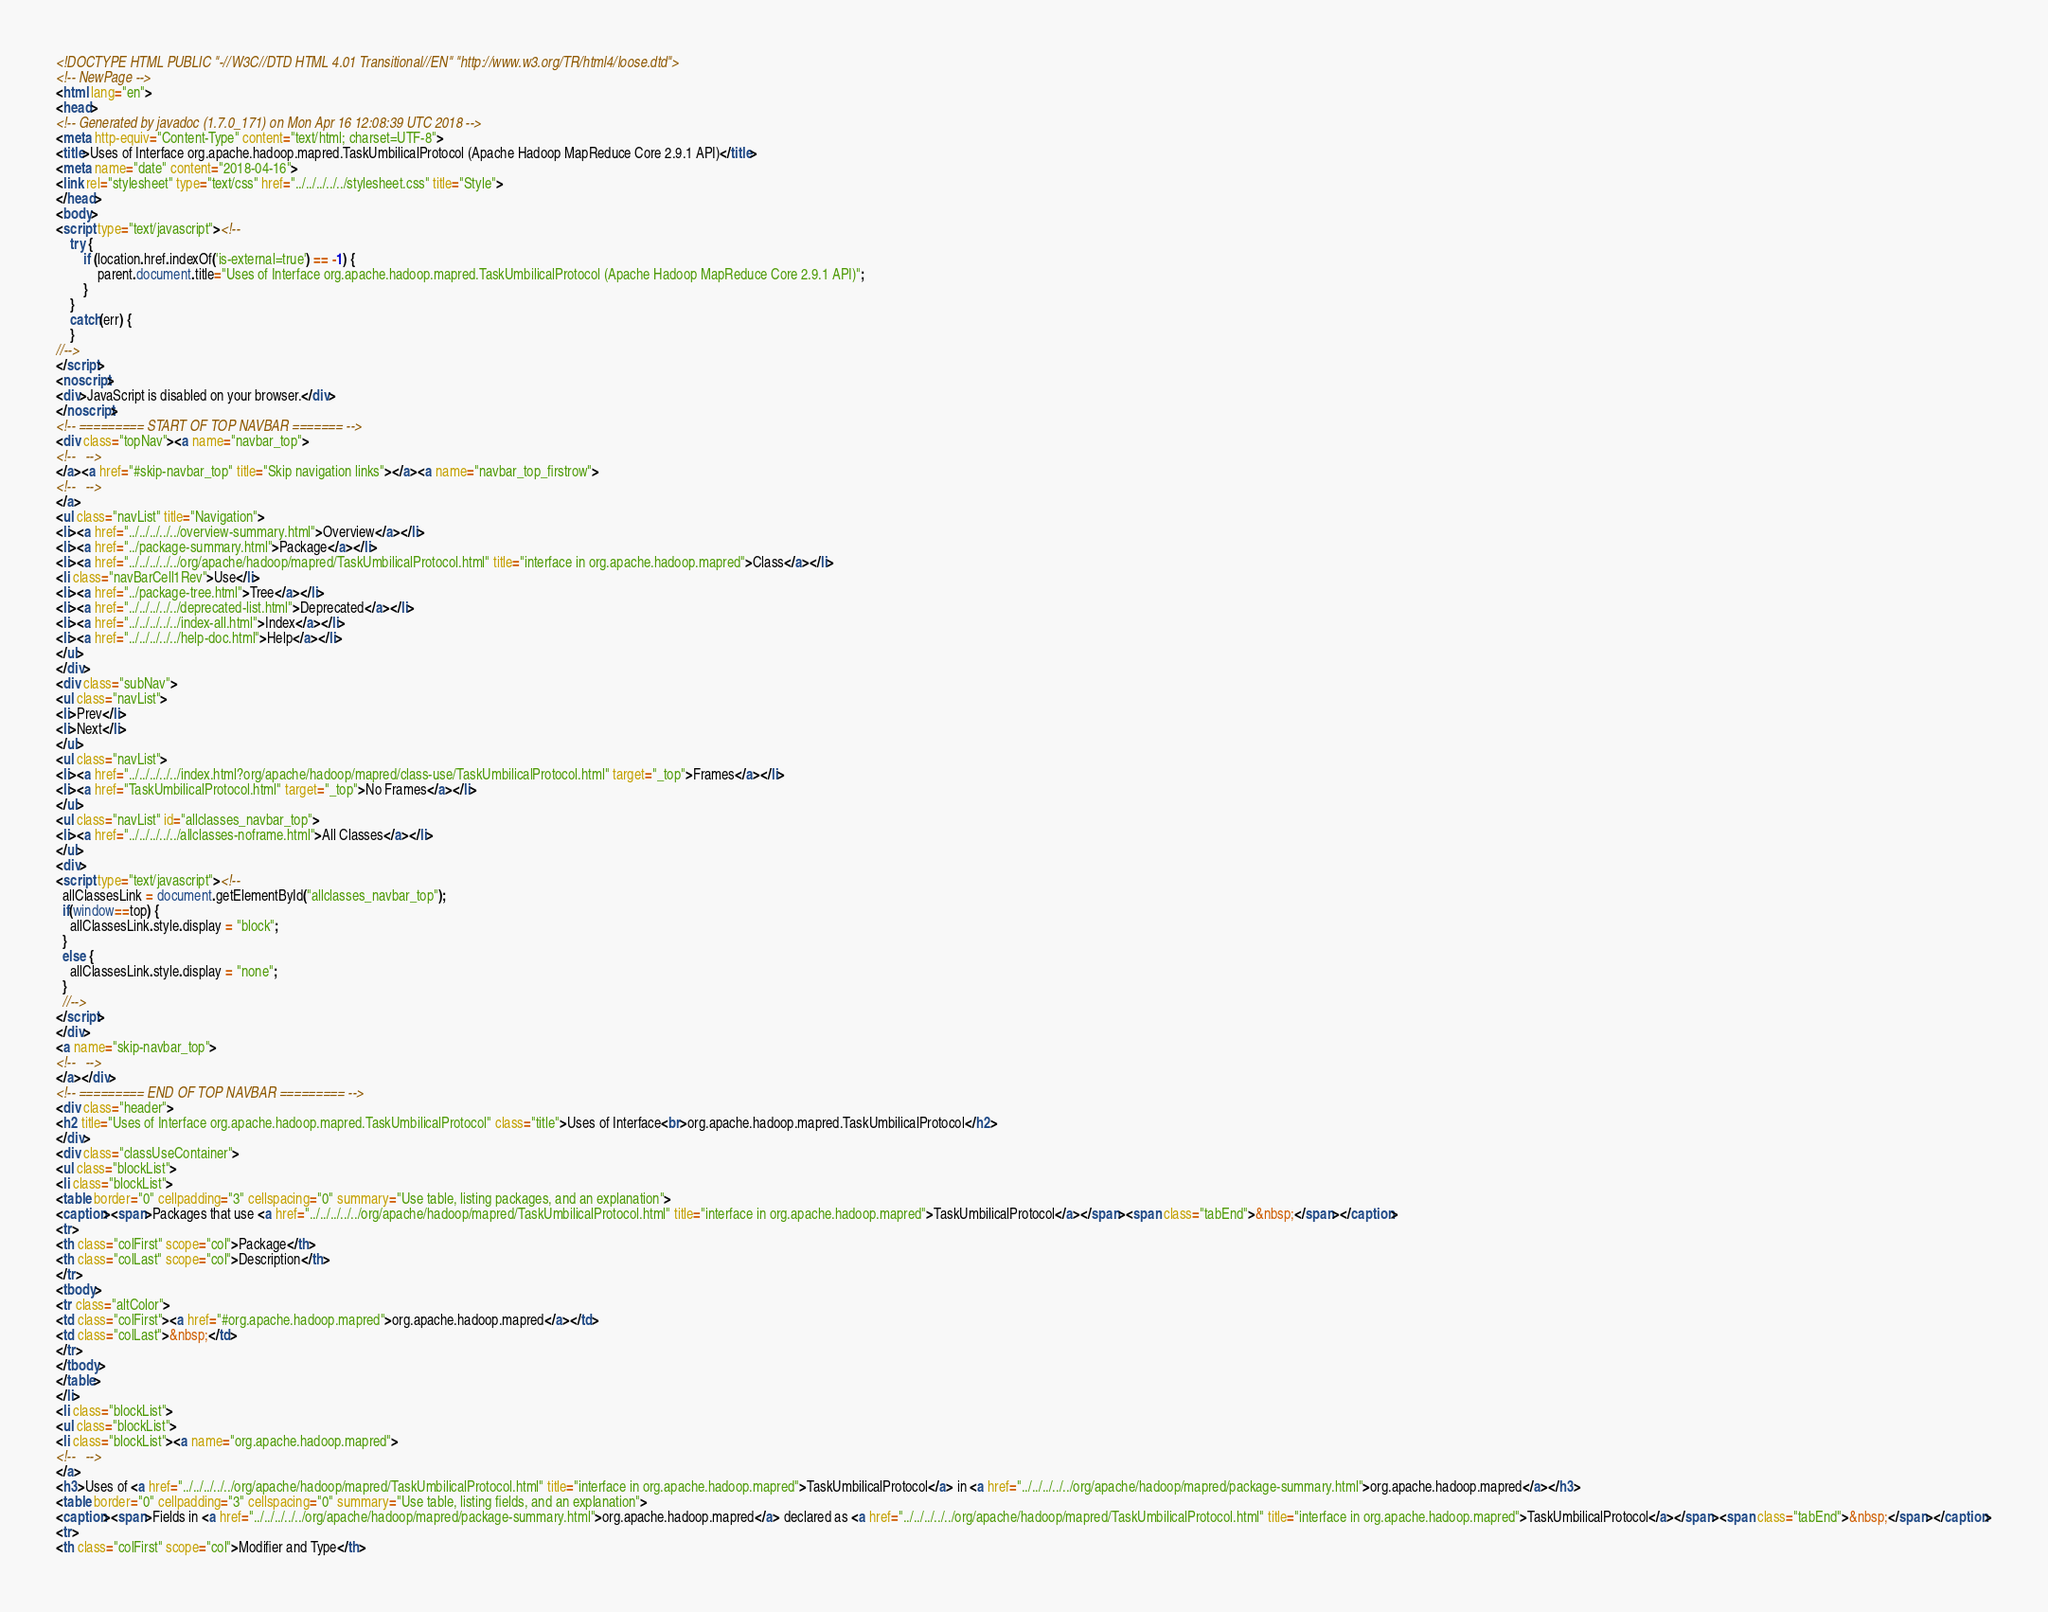Convert code to text. <code><loc_0><loc_0><loc_500><loc_500><_HTML_><!DOCTYPE HTML PUBLIC "-//W3C//DTD HTML 4.01 Transitional//EN" "http://www.w3.org/TR/html4/loose.dtd">
<!-- NewPage -->
<html lang="en">
<head>
<!-- Generated by javadoc (1.7.0_171) on Mon Apr 16 12:08:39 UTC 2018 -->
<meta http-equiv="Content-Type" content="text/html; charset=UTF-8">
<title>Uses of Interface org.apache.hadoop.mapred.TaskUmbilicalProtocol (Apache Hadoop MapReduce Core 2.9.1 API)</title>
<meta name="date" content="2018-04-16">
<link rel="stylesheet" type="text/css" href="../../../../../stylesheet.css" title="Style">
</head>
<body>
<script type="text/javascript"><!--
    try {
        if (location.href.indexOf('is-external=true') == -1) {
            parent.document.title="Uses of Interface org.apache.hadoop.mapred.TaskUmbilicalProtocol (Apache Hadoop MapReduce Core 2.9.1 API)";
        }
    }
    catch(err) {
    }
//-->
</script>
<noscript>
<div>JavaScript is disabled on your browser.</div>
</noscript>
<!-- ========= START OF TOP NAVBAR ======= -->
<div class="topNav"><a name="navbar_top">
<!--   -->
</a><a href="#skip-navbar_top" title="Skip navigation links"></a><a name="navbar_top_firstrow">
<!--   -->
</a>
<ul class="navList" title="Navigation">
<li><a href="../../../../../overview-summary.html">Overview</a></li>
<li><a href="../package-summary.html">Package</a></li>
<li><a href="../../../../../org/apache/hadoop/mapred/TaskUmbilicalProtocol.html" title="interface in org.apache.hadoop.mapred">Class</a></li>
<li class="navBarCell1Rev">Use</li>
<li><a href="../package-tree.html">Tree</a></li>
<li><a href="../../../../../deprecated-list.html">Deprecated</a></li>
<li><a href="../../../../../index-all.html">Index</a></li>
<li><a href="../../../../../help-doc.html">Help</a></li>
</ul>
</div>
<div class="subNav">
<ul class="navList">
<li>Prev</li>
<li>Next</li>
</ul>
<ul class="navList">
<li><a href="../../../../../index.html?org/apache/hadoop/mapred/class-use/TaskUmbilicalProtocol.html" target="_top">Frames</a></li>
<li><a href="TaskUmbilicalProtocol.html" target="_top">No Frames</a></li>
</ul>
<ul class="navList" id="allclasses_navbar_top">
<li><a href="../../../../../allclasses-noframe.html">All Classes</a></li>
</ul>
<div>
<script type="text/javascript"><!--
  allClassesLink = document.getElementById("allclasses_navbar_top");
  if(window==top) {
    allClassesLink.style.display = "block";
  }
  else {
    allClassesLink.style.display = "none";
  }
  //-->
</script>
</div>
<a name="skip-navbar_top">
<!--   -->
</a></div>
<!-- ========= END OF TOP NAVBAR ========= -->
<div class="header">
<h2 title="Uses of Interface org.apache.hadoop.mapred.TaskUmbilicalProtocol" class="title">Uses of Interface<br>org.apache.hadoop.mapred.TaskUmbilicalProtocol</h2>
</div>
<div class="classUseContainer">
<ul class="blockList">
<li class="blockList">
<table border="0" cellpadding="3" cellspacing="0" summary="Use table, listing packages, and an explanation">
<caption><span>Packages that use <a href="../../../../../org/apache/hadoop/mapred/TaskUmbilicalProtocol.html" title="interface in org.apache.hadoop.mapred">TaskUmbilicalProtocol</a></span><span class="tabEnd">&nbsp;</span></caption>
<tr>
<th class="colFirst" scope="col">Package</th>
<th class="colLast" scope="col">Description</th>
</tr>
<tbody>
<tr class="altColor">
<td class="colFirst"><a href="#org.apache.hadoop.mapred">org.apache.hadoop.mapred</a></td>
<td class="colLast">&nbsp;</td>
</tr>
</tbody>
</table>
</li>
<li class="blockList">
<ul class="blockList">
<li class="blockList"><a name="org.apache.hadoop.mapred">
<!--   -->
</a>
<h3>Uses of <a href="../../../../../org/apache/hadoop/mapred/TaskUmbilicalProtocol.html" title="interface in org.apache.hadoop.mapred">TaskUmbilicalProtocol</a> in <a href="../../../../../org/apache/hadoop/mapred/package-summary.html">org.apache.hadoop.mapred</a></h3>
<table border="0" cellpadding="3" cellspacing="0" summary="Use table, listing fields, and an explanation">
<caption><span>Fields in <a href="../../../../../org/apache/hadoop/mapred/package-summary.html">org.apache.hadoop.mapred</a> declared as <a href="../../../../../org/apache/hadoop/mapred/TaskUmbilicalProtocol.html" title="interface in org.apache.hadoop.mapred">TaskUmbilicalProtocol</a></span><span class="tabEnd">&nbsp;</span></caption>
<tr>
<th class="colFirst" scope="col">Modifier and Type</th></code> 